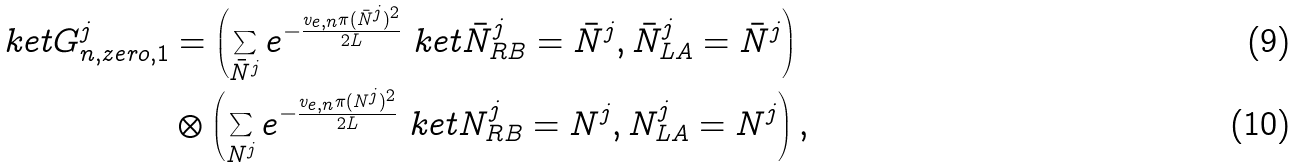Convert formula to latex. <formula><loc_0><loc_0><loc_500><loc_500>\ k e t { G _ { n , z e r o , 1 } ^ { j } } & = \left ( \sum _ { \bar { N } ^ { j } } e ^ { - \frac { v _ { e , n } \pi ( \bar { N } ^ { j } ) ^ { 2 } } { 2 L } } \ k e t { \bar { N } _ { R B } ^ { j } = \bar { N } ^ { j } , \bar { N } _ { L A } ^ { j } = \bar { N } ^ { j } } \right ) \\ & \otimes \left ( \sum _ { N ^ { j } } e ^ { - \frac { v _ { e , n } \pi ( N ^ { j } ) ^ { 2 } } { 2 L } } \ k e t { N _ { R B } ^ { j } = N ^ { j } , N _ { L A } ^ { j } = N ^ { j } } \right ) ,</formula> 